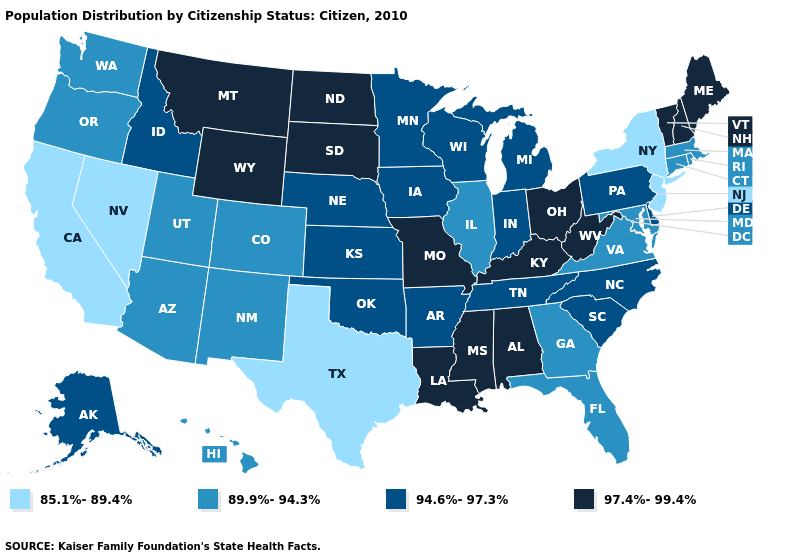What is the value of North Carolina?
Concise answer only. 94.6%-97.3%. What is the value of Hawaii?
Concise answer only. 89.9%-94.3%. What is the value of North Carolina?
Answer briefly. 94.6%-97.3%. What is the value of Connecticut?
Concise answer only. 89.9%-94.3%. What is the value of Colorado?
Answer briefly. 89.9%-94.3%. What is the highest value in the West ?
Quick response, please. 97.4%-99.4%. Which states hav the highest value in the MidWest?
Concise answer only. Missouri, North Dakota, Ohio, South Dakota. Among the states that border Minnesota , does North Dakota have the lowest value?
Write a very short answer. No. Does Rhode Island have a lower value than Nevada?
Short answer required. No. Which states have the lowest value in the USA?
Be succinct. California, Nevada, New Jersey, New York, Texas. Among the states that border New Jersey , does New York have the lowest value?
Write a very short answer. Yes. Name the states that have a value in the range 94.6%-97.3%?
Quick response, please. Alaska, Arkansas, Delaware, Idaho, Indiana, Iowa, Kansas, Michigan, Minnesota, Nebraska, North Carolina, Oklahoma, Pennsylvania, South Carolina, Tennessee, Wisconsin. Does the map have missing data?
Short answer required. No. Name the states that have a value in the range 89.9%-94.3%?
Keep it brief. Arizona, Colorado, Connecticut, Florida, Georgia, Hawaii, Illinois, Maryland, Massachusetts, New Mexico, Oregon, Rhode Island, Utah, Virginia, Washington. Does New Jersey have the lowest value in the Northeast?
Concise answer only. Yes. 